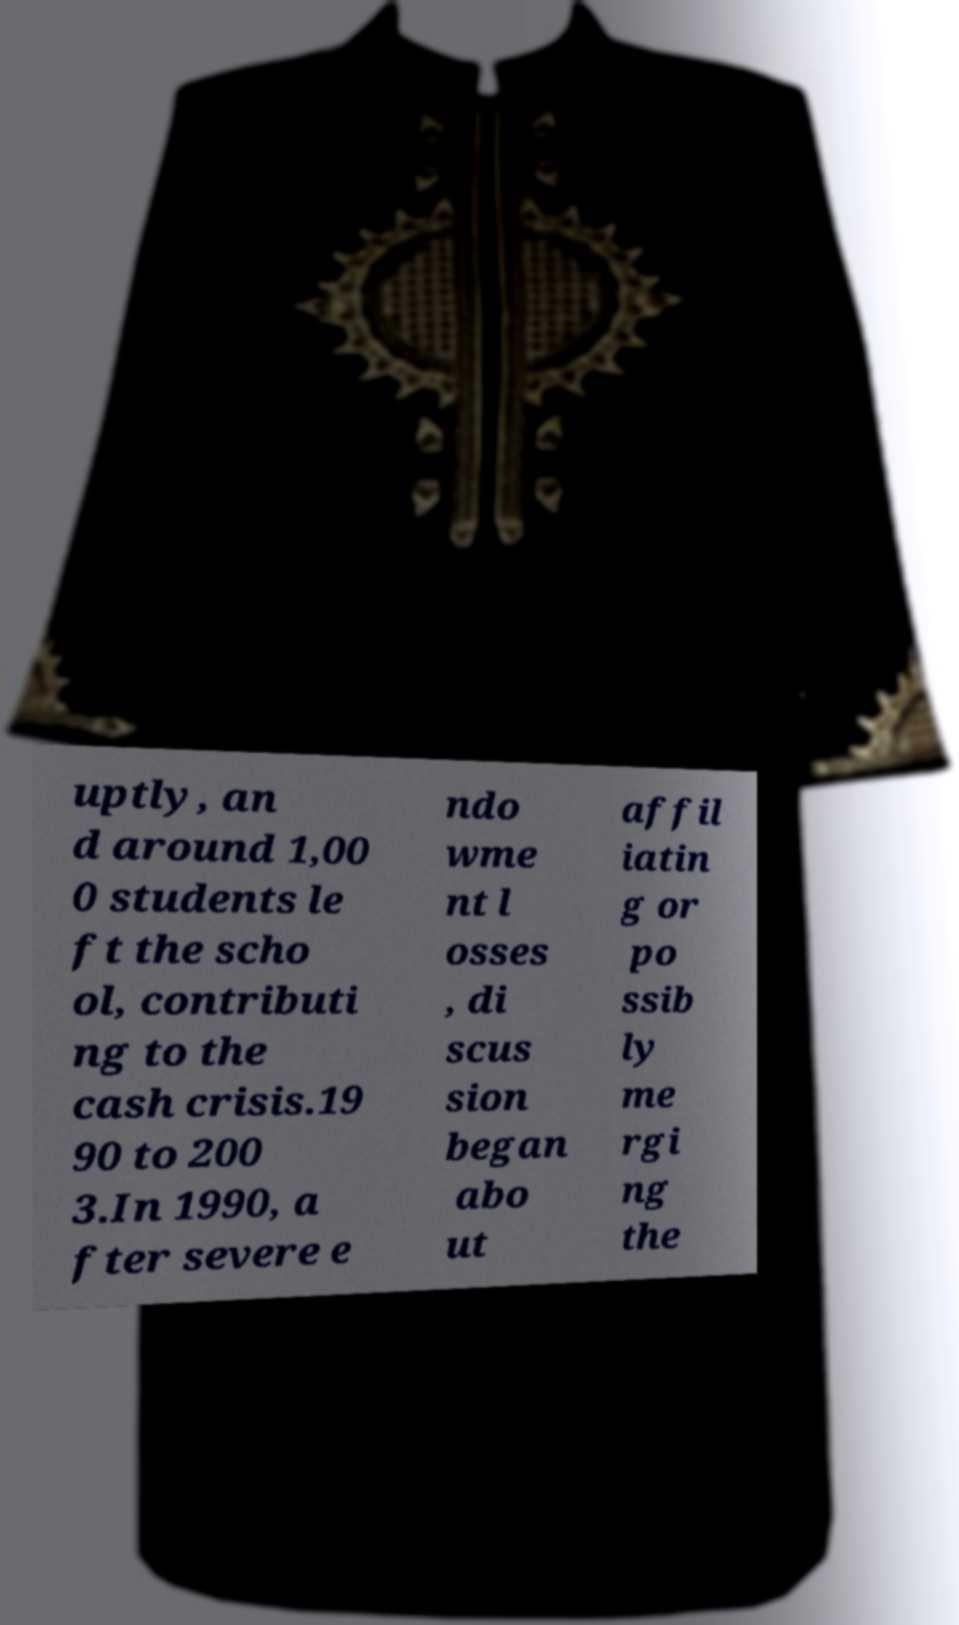Could you extract and type out the text from this image? uptly, an d around 1,00 0 students le ft the scho ol, contributi ng to the cash crisis.19 90 to 200 3.In 1990, a fter severe e ndo wme nt l osses , di scus sion began abo ut affil iatin g or po ssib ly me rgi ng the 